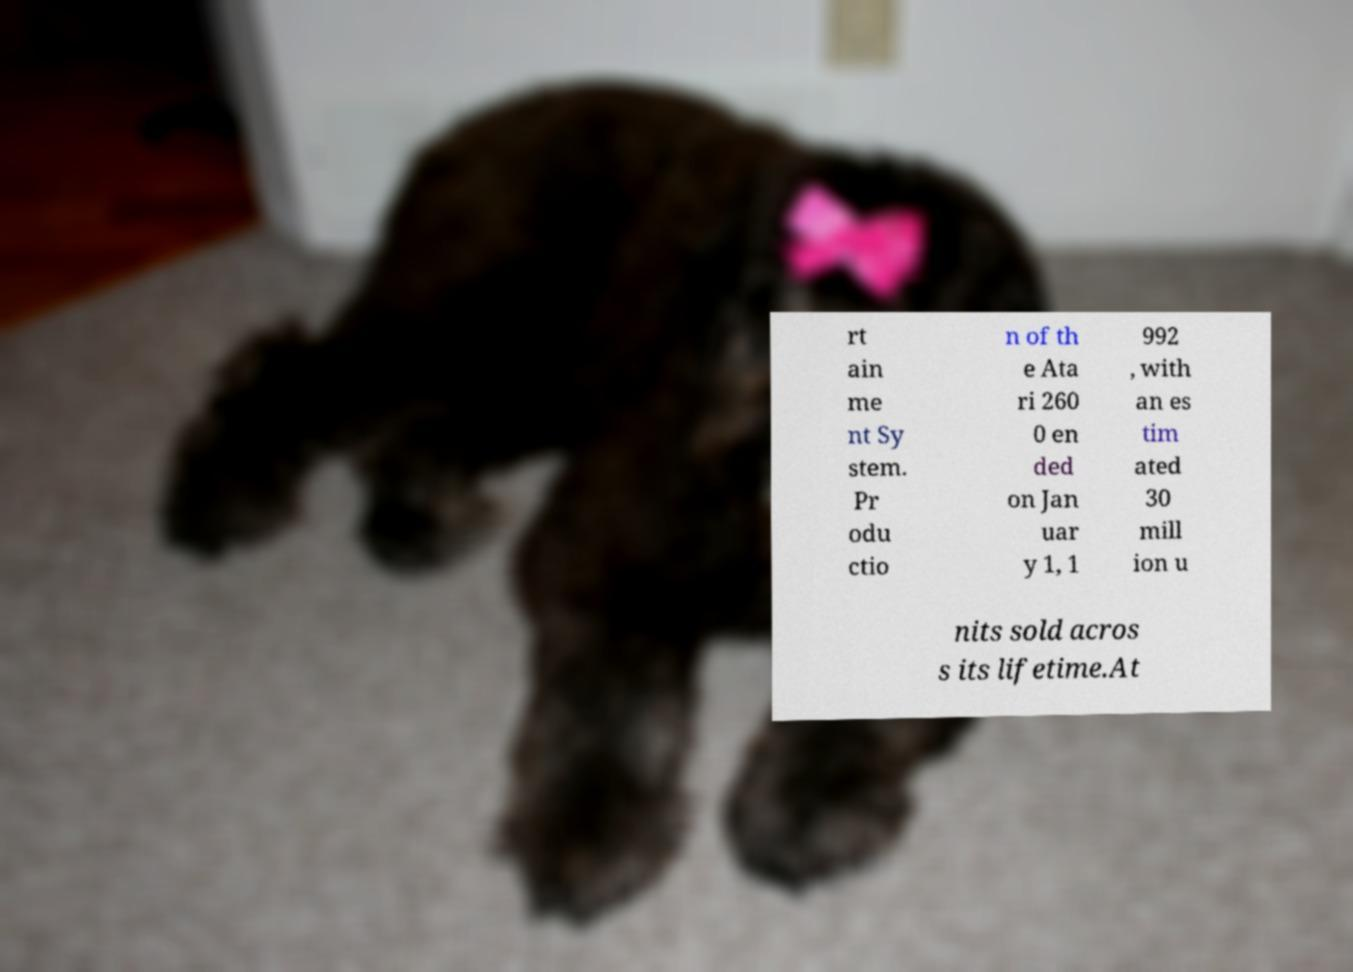I need the written content from this picture converted into text. Can you do that? rt ain me nt Sy stem. Pr odu ctio n of th e Ata ri 260 0 en ded on Jan uar y 1, 1 992 , with an es tim ated 30 mill ion u nits sold acros s its lifetime.At 